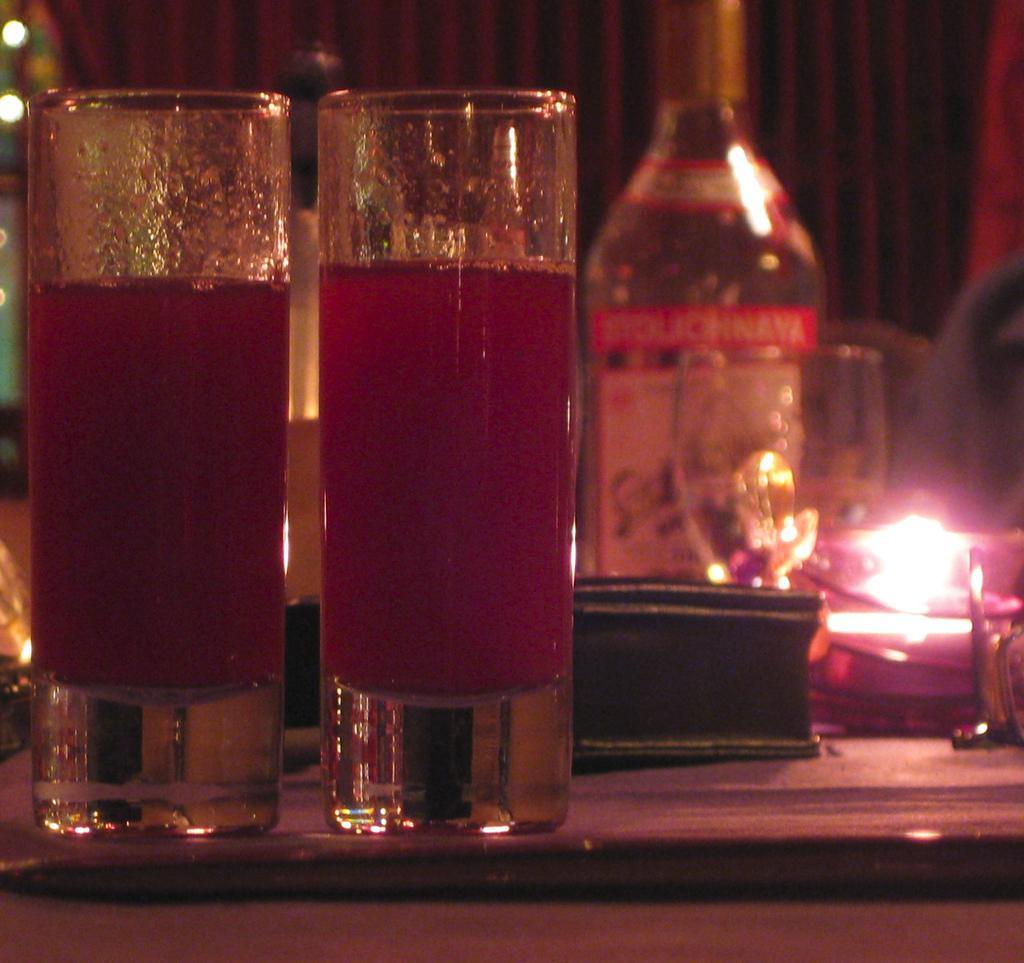Please provide a concise description of this image. In this picture there are two glasses which contains juice in it and there is a bottle at the right side of the image which are placed on the table. 